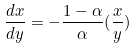<formula> <loc_0><loc_0><loc_500><loc_500>\frac { d x } { d y } = - \frac { 1 - \alpha } { \alpha } ( \frac { x } { y } )</formula> 